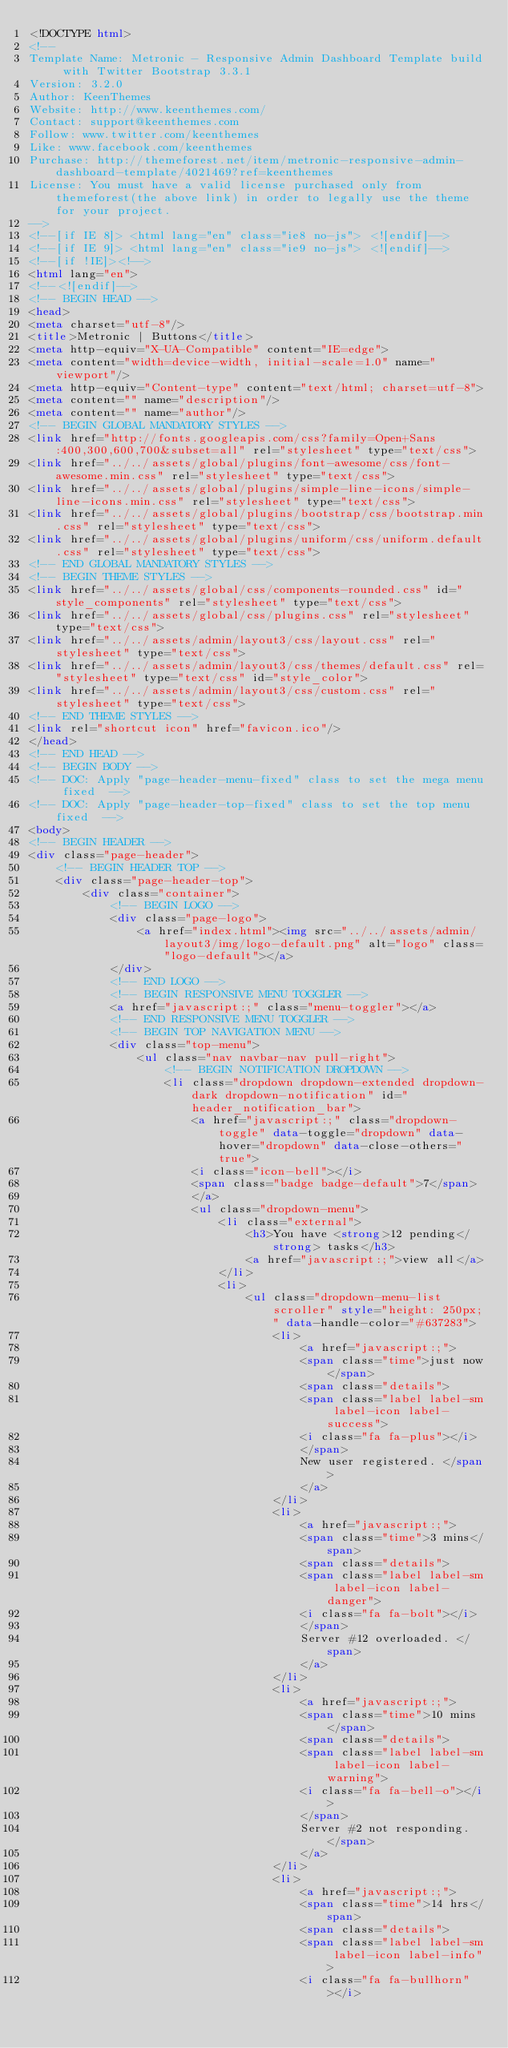Convert code to text. <code><loc_0><loc_0><loc_500><loc_500><_HTML_><!DOCTYPE html>
<!-- 
Template Name: Metronic - Responsive Admin Dashboard Template build with Twitter Bootstrap 3.3.1
Version: 3.2.0
Author: KeenThemes
Website: http://www.keenthemes.com/
Contact: support@keenthemes.com
Follow: www.twitter.com/keenthemes
Like: www.facebook.com/keenthemes
Purchase: http://themeforest.net/item/metronic-responsive-admin-dashboard-template/4021469?ref=keenthemes
License: You must have a valid license purchased only from themeforest(the above link) in order to legally use the theme for your project.
-->
<!--[if IE 8]> <html lang="en" class="ie8 no-js"> <![endif]-->
<!--[if IE 9]> <html lang="en" class="ie9 no-js"> <![endif]-->
<!--[if !IE]><!-->
<html lang="en">
<!--<![endif]-->
<!-- BEGIN HEAD -->
<head>
<meta charset="utf-8"/>
<title>Metronic | Buttons</title>
<meta http-equiv="X-UA-Compatible" content="IE=edge">
<meta content="width=device-width, initial-scale=1.0" name="viewport"/>
<meta http-equiv="Content-type" content="text/html; charset=utf-8">
<meta content="" name="description"/>
<meta content="" name="author"/>
<!-- BEGIN GLOBAL MANDATORY STYLES -->
<link href="http://fonts.googleapis.com/css?family=Open+Sans:400,300,600,700&subset=all" rel="stylesheet" type="text/css">
<link href="../../assets/global/plugins/font-awesome/css/font-awesome.min.css" rel="stylesheet" type="text/css">
<link href="../../assets/global/plugins/simple-line-icons/simple-line-icons.min.css" rel="stylesheet" type="text/css">
<link href="../../assets/global/plugins/bootstrap/css/bootstrap.min.css" rel="stylesheet" type="text/css">
<link href="../../assets/global/plugins/uniform/css/uniform.default.css" rel="stylesheet" type="text/css">
<!-- END GLOBAL MANDATORY STYLES -->
<!-- BEGIN THEME STYLES -->
<link href="../../assets/global/css/components-rounded.css" id="style_components" rel="stylesheet" type="text/css">
<link href="../../assets/global/css/plugins.css" rel="stylesheet" type="text/css">
<link href="../../assets/admin/layout3/css/layout.css" rel="stylesheet" type="text/css">
<link href="../../assets/admin/layout3/css/themes/default.css" rel="stylesheet" type="text/css" id="style_color">
<link href="../../assets/admin/layout3/css/custom.css" rel="stylesheet" type="text/css">
<!-- END THEME STYLES -->
<link rel="shortcut icon" href="favicon.ico"/>
</head>
<!-- END HEAD -->
<!-- BEGIN BODY -->
<!-- DOC: Apply "page-header-menu-fixed" class to set the mega menu fixed  -->
<!-- DOC: Apply "page-header-top-fixed" class to set the top menu fixed  -->
<body>
<!-- BEGIN HEADER -->
<div class="page-header">
	<!-- BEGIN HEADER TOP -->
	<div class="page-header-top">
		<div class="container">
			<!-- BEGIN LOGO -->
			<div class="page-logo">
				<a href="index.html"><img src="../../assets/admin/layout3/img/logo-default.png" alt="logo" class="logo-default"></a>
			</div>
			<!-- END LOGO -->
			<!-- BEGIN RESPONSIVE MENU TOGGLER -->
			<a href="javascript:;" class="menu-toggler"></a>
			<!-- END RESPONSIVE MENU TOGGLER -->
			<!-- BEGIN TOP NAVIGATION MENU -->
			<div class="top-menu">
				<ul class="nav navbar-nav pull-right">
					<!-- BEGIN NOTIFICATION DROPDOWN -->
					<li class="dropdown dropdown-extended dropdown-dark dropdown-notification" id="header_notification_bar">
						<a href="javascript:;" class="dropdown-toggle" data-toggle="dropdown" data-hover="dropdown" data-close-others="true">
						<i class="icon-bell"></i>
						<span class="badge badge-default">7</span>
						</a>
						<ul class="dropdown-menu">
							<li class="external">
								<h3>You have <strong>12 pending</strong> tasks</h3>
								<a href="javascript:;">view all</a>
							</li>
							<li>
								<ul class="dropdown-menu-list scroller" style="height: 250px;" data-handle-color="#637283">
									<li>
										<a href="javascript:;">
										<span class="time">just now</span>
										<span class="details">
										<span class="label label-sm label-icon label-success">
										<i class="fa fa-plus"></i>
										</span>
										New user registered. </span>
										</a>
									</li>
									<li>
										<a href="javascript:;">
										<span class="time">3 mins</span>
										<span class="details">
										<span class="label label-sm label-icon label-danger">
										<i class="fa fa-bolt"></i>
										</span>
										Server #12 overloaded. </span>
										</a>
									</li>
									<li>
										<a href="javascript:;">
										<span class="time">10 mins</span>
										<span class="details">
										<span class="label label-sm label-icon label-warning">
										<i class="fa fa-bell-o"></i>
										</span>
										Server #2 not responding. </span>
										</a>
									</li>
									<li>
										<a href="javascript:;">
										<span class="time">14 hrs</span>
										<span class="details">
										<span class="label label-sm label-icon label-info">
										<i class="fa fa-bullhorn"></i></code> 